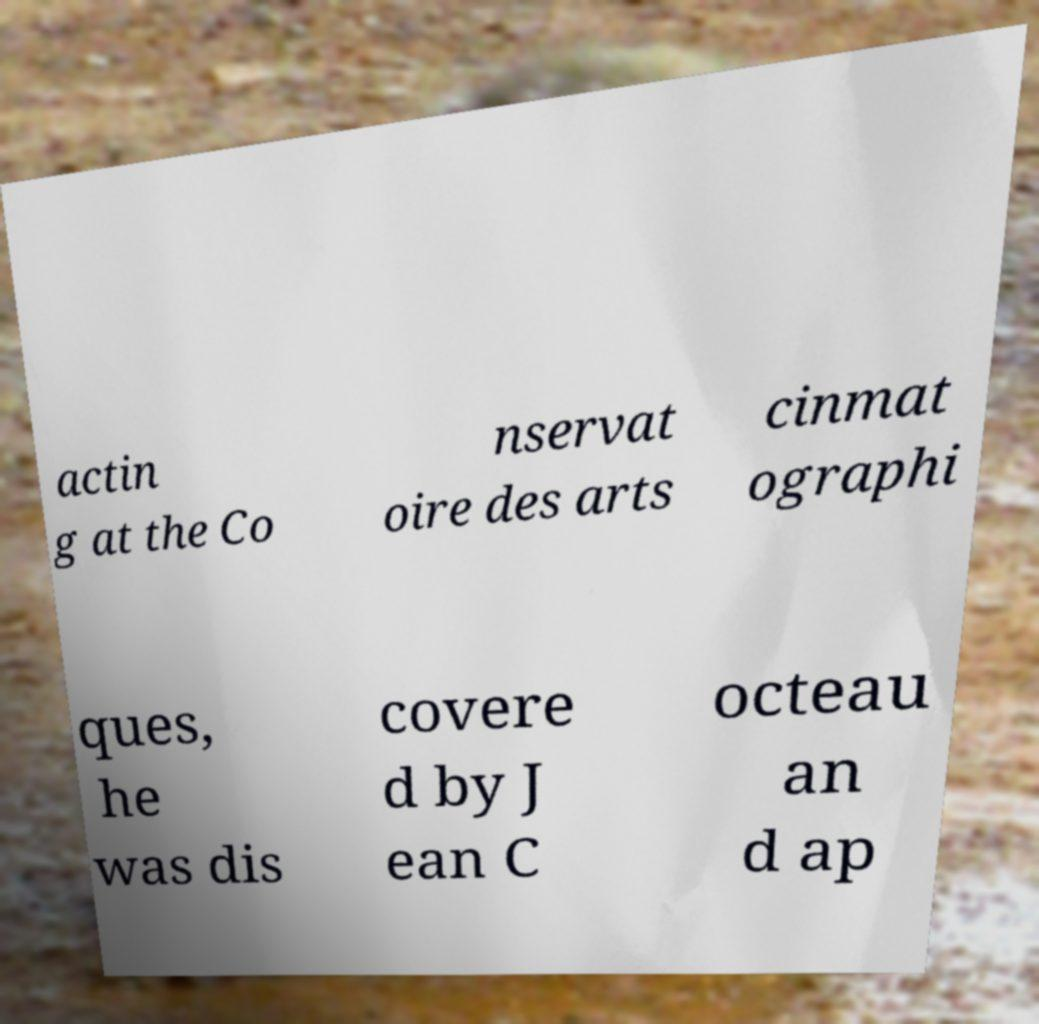Can you read and provide the text displayed in the image?This photo seems to have some interesting text. Can you extract and type it out for me? actin g at the Co nservat oire des arts cinmat ographi ques, he was dis covere d by J ean C octeau an d ap 